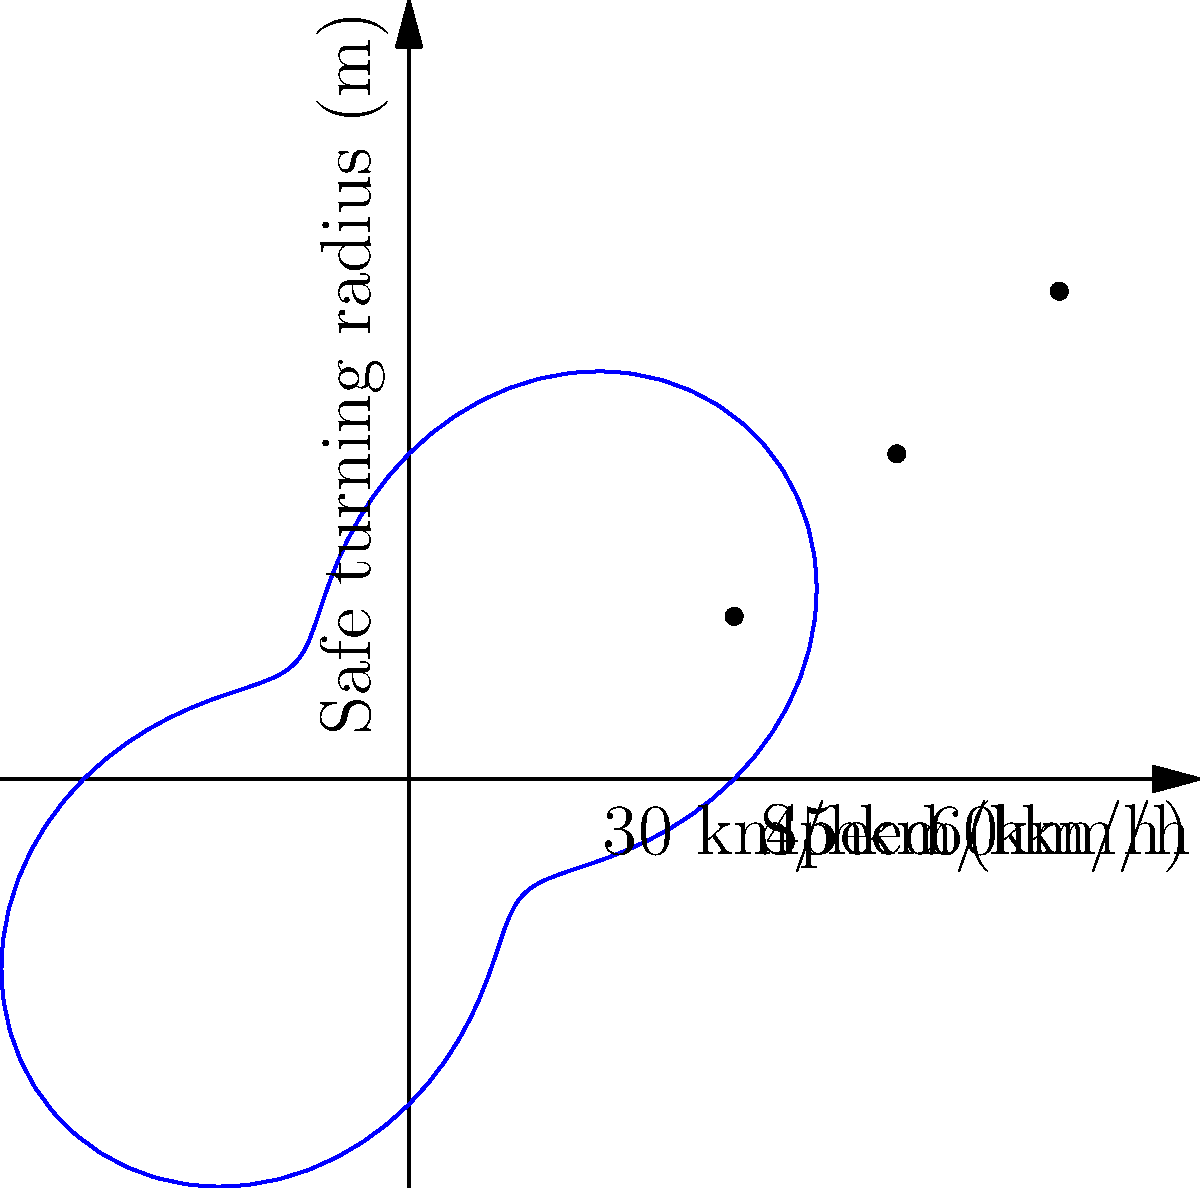As a health-conscious yoga instructor concerned about your sibling's safety during rides, you come across a polar graph representing the safe turning radius of a vehicle at different speeds. The curve is given by the equation $r = 30 + 15\sin(2\theta)$, where $r$ is the safe turning radius in meters and $\theta$ is related to the speed. If $\theta = \frac{\pi}{4}$ corresponds to a speed of 45 km/h, what is the safe turning radius at this speed? To find the safe turning radius at 45 km/h, we need to follow these steps:

1) We are given that $\theta = \frac{\pi}{4}$ corresponds to 45 km/h.

2) The equation for the safe turning radius is $r = 30 + 15\sin(2\theta)$.

3) We need to substitute $\theta = \frac{\pi}{4}$ into this equation:

   $r = 30 + 15\sin(2 \cdot \frac{\pi}{4})$

4) Simplify the argument of sine:
   
   $r = 30 + 15\sin(\frac{\pi}{2})$

5) Recall that $\sin(\frac{\pi}{2}) = 1$:

   $r = 30 + 15 \cdot 1$

6) Perform the final calculation:

   $r = 30 + 15 = 45$

Therefore, at a speed of 45 km/h, the safe turning radius is 45 meters.
Answer: 45 meters 